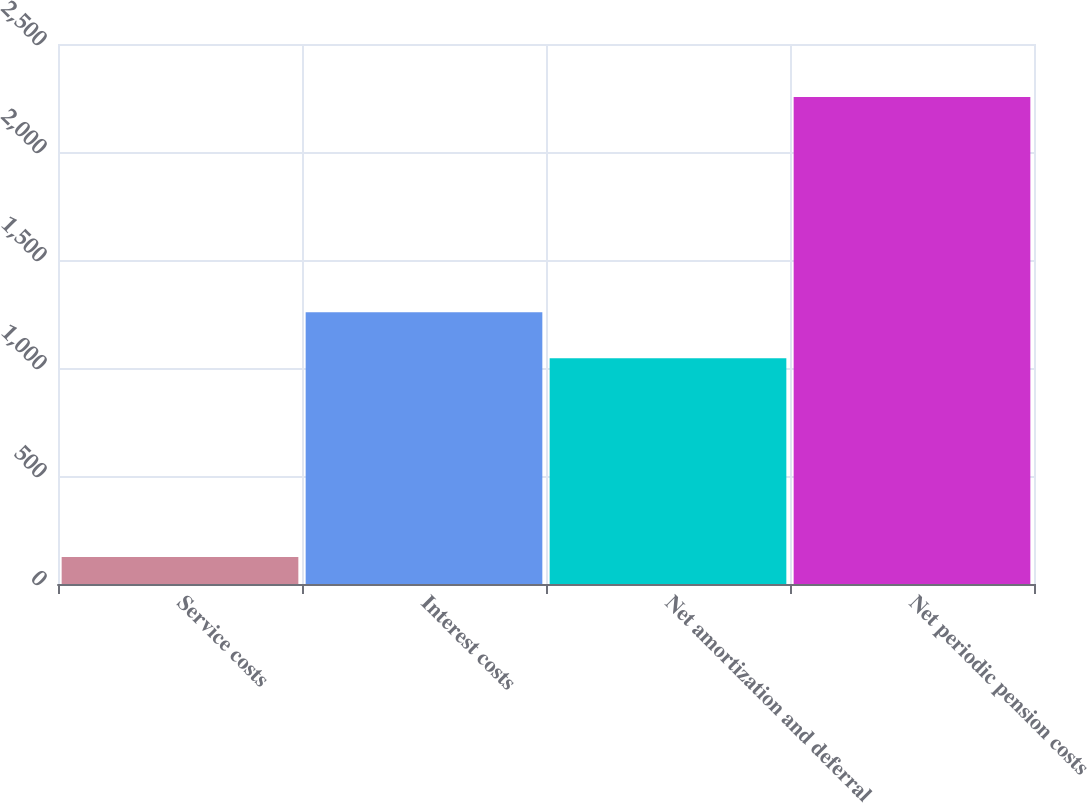Convert chart to OTSL. <chart><loc_0><loc_0><loc_500><loc_500><bar_chart><fcel>Service costs<fcel>Interest costs<fcel>Net amortization and deferral<fcel>Net periodic pension costs<nl><fcel>125<fcel>1258<fcel>1045<fcel>2255<nl></chart> 